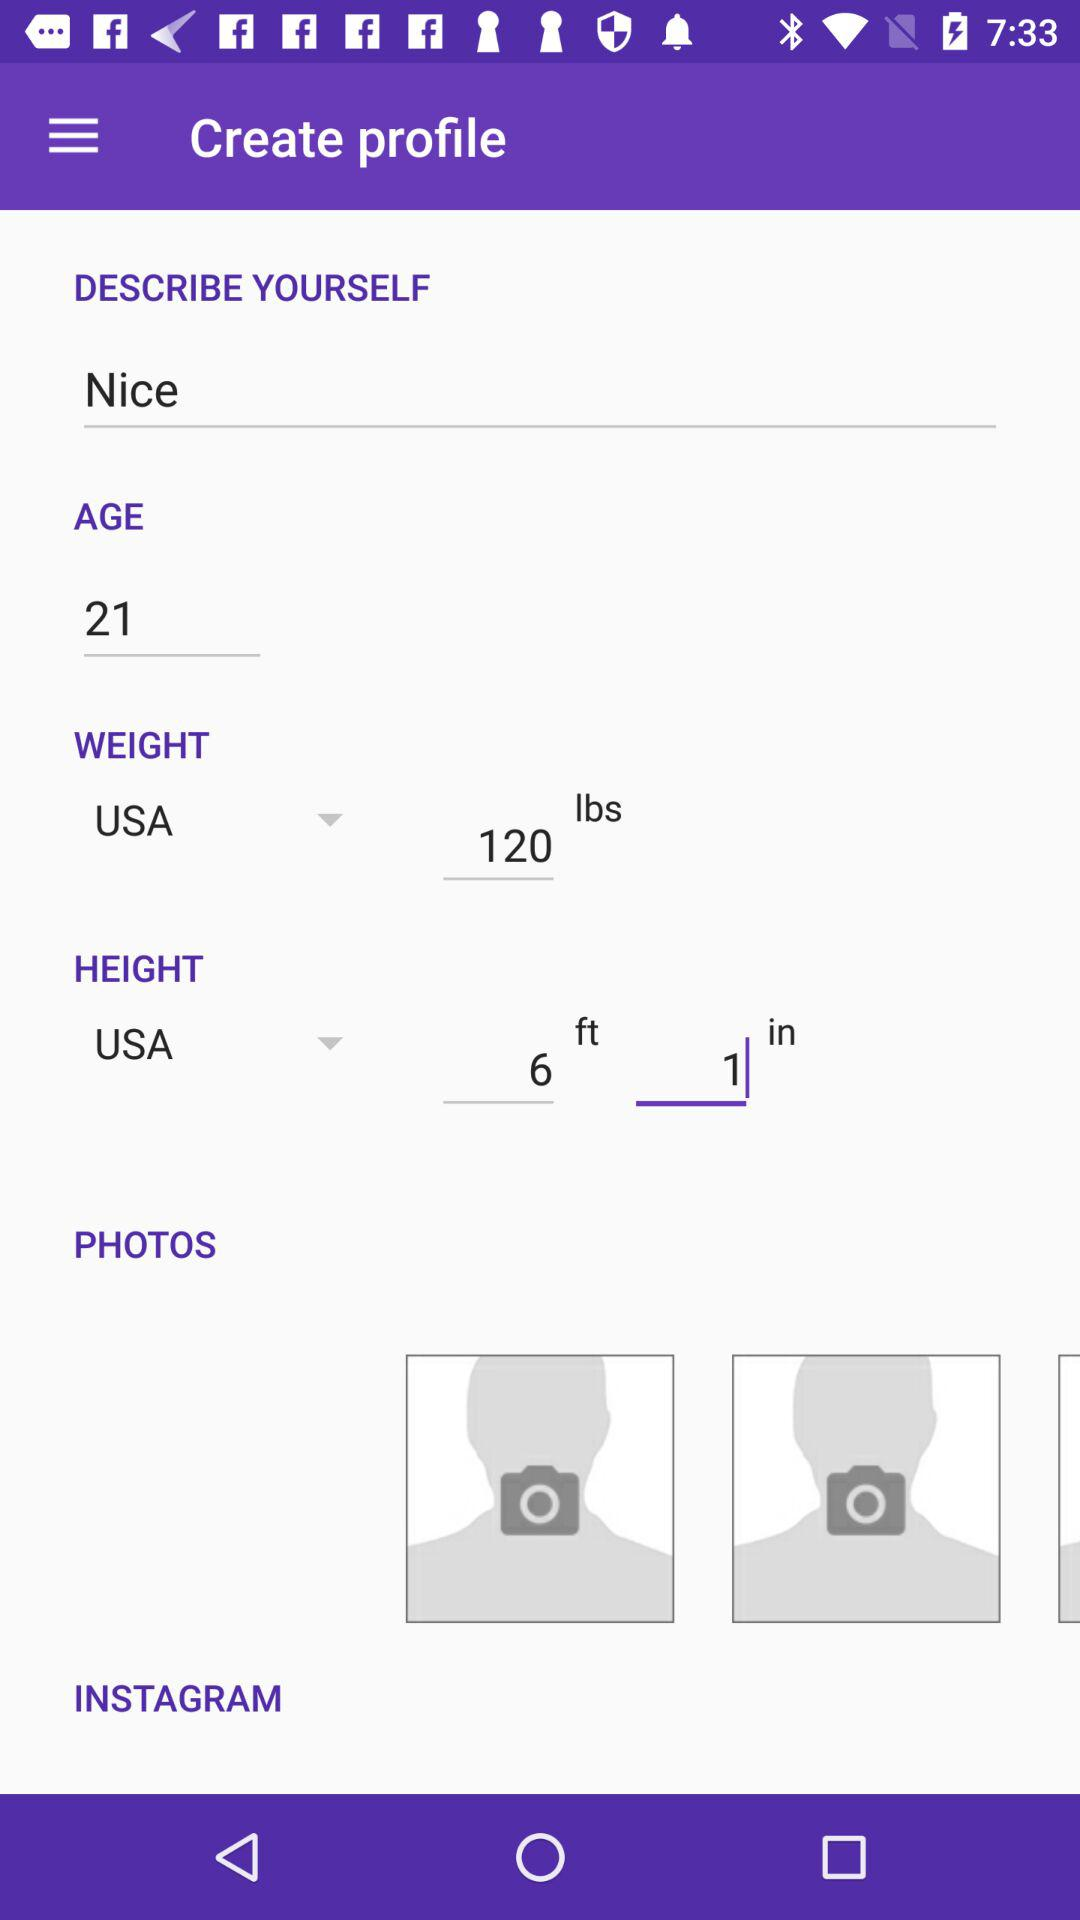How many text inputs are there for the profile information?
Answer the question using a single word or phrase. 4 